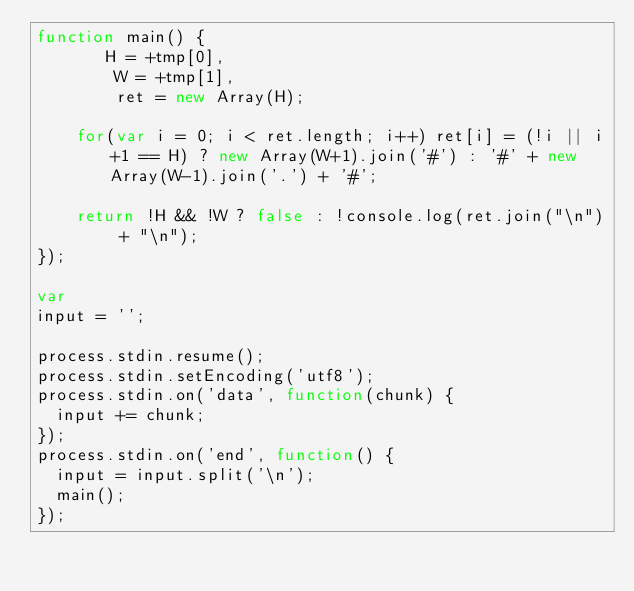Convert code to text. <code><loc_0><loc_0><loc_500><loc_500><_JavaScript_>function main() {
       H = +tmp[0],
        W = +tmp[1],
        ret = new Array(H);
  
    for(var i = 0; i < ret.length; i++) ret[i] = (!i || i+1 == H) ? new Array(W+1).join('#') : '#' + new Array(W-1).join('.') + '#';
  
    return !H && !W ? false : !console.log(ret.join("\n") + "\n");
});
 
var
input = '';
 
process.stdin.resume();
process.stdin.setEncoding('utf8');
process.stdin.on('data', function(chunk) {
  input += chunk;
});
process.stdin.on('end', function() {
  input = input.split('\n');
  main();
});</code> 